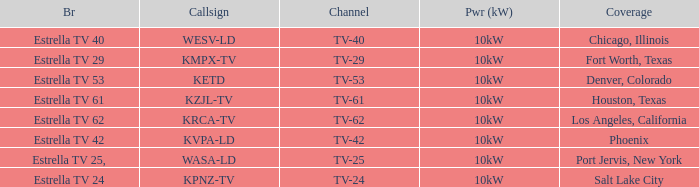Could you parse the entire table? {'header': ['Br', 'Callsign', 'Channel', 'Pwr (kW)', 'Coverage'], 'rows': [['Estrella TV 40', 'WESV-LD', 'TV-40', '10kW', 'Chicago, Illinois'], ['Estrella TV 29', 'KMPX-TV', 'TV-29', '10kW', 'Fort Worth, Texas'], ['Estrella TV 53', 'KETD', 'TV-53', '10kW', 'Denver, Colorado'], ['Estrella TV 61', 'KZJL-TV', 'TV-61', '10kW', 'Houston, Texas'], ['Estrella TV 62', 'KRCA-TV', 'TV-62', '10kW', 'Los Angeles, California'], ['Estrella TV 42', 'KVPA-LD', 'TV-42', '10kW', 'Phoenix'], ['Estrella TV 25,', 'WASA-LD', 'TV-25', '10kW', 'Port Jervis, New York'], ['Estrella TV 24', 'KPNZ-TV', 'TV-24', '10kW', 'Salt Lake City']]} List the power output for Phoenix.  10kW. 